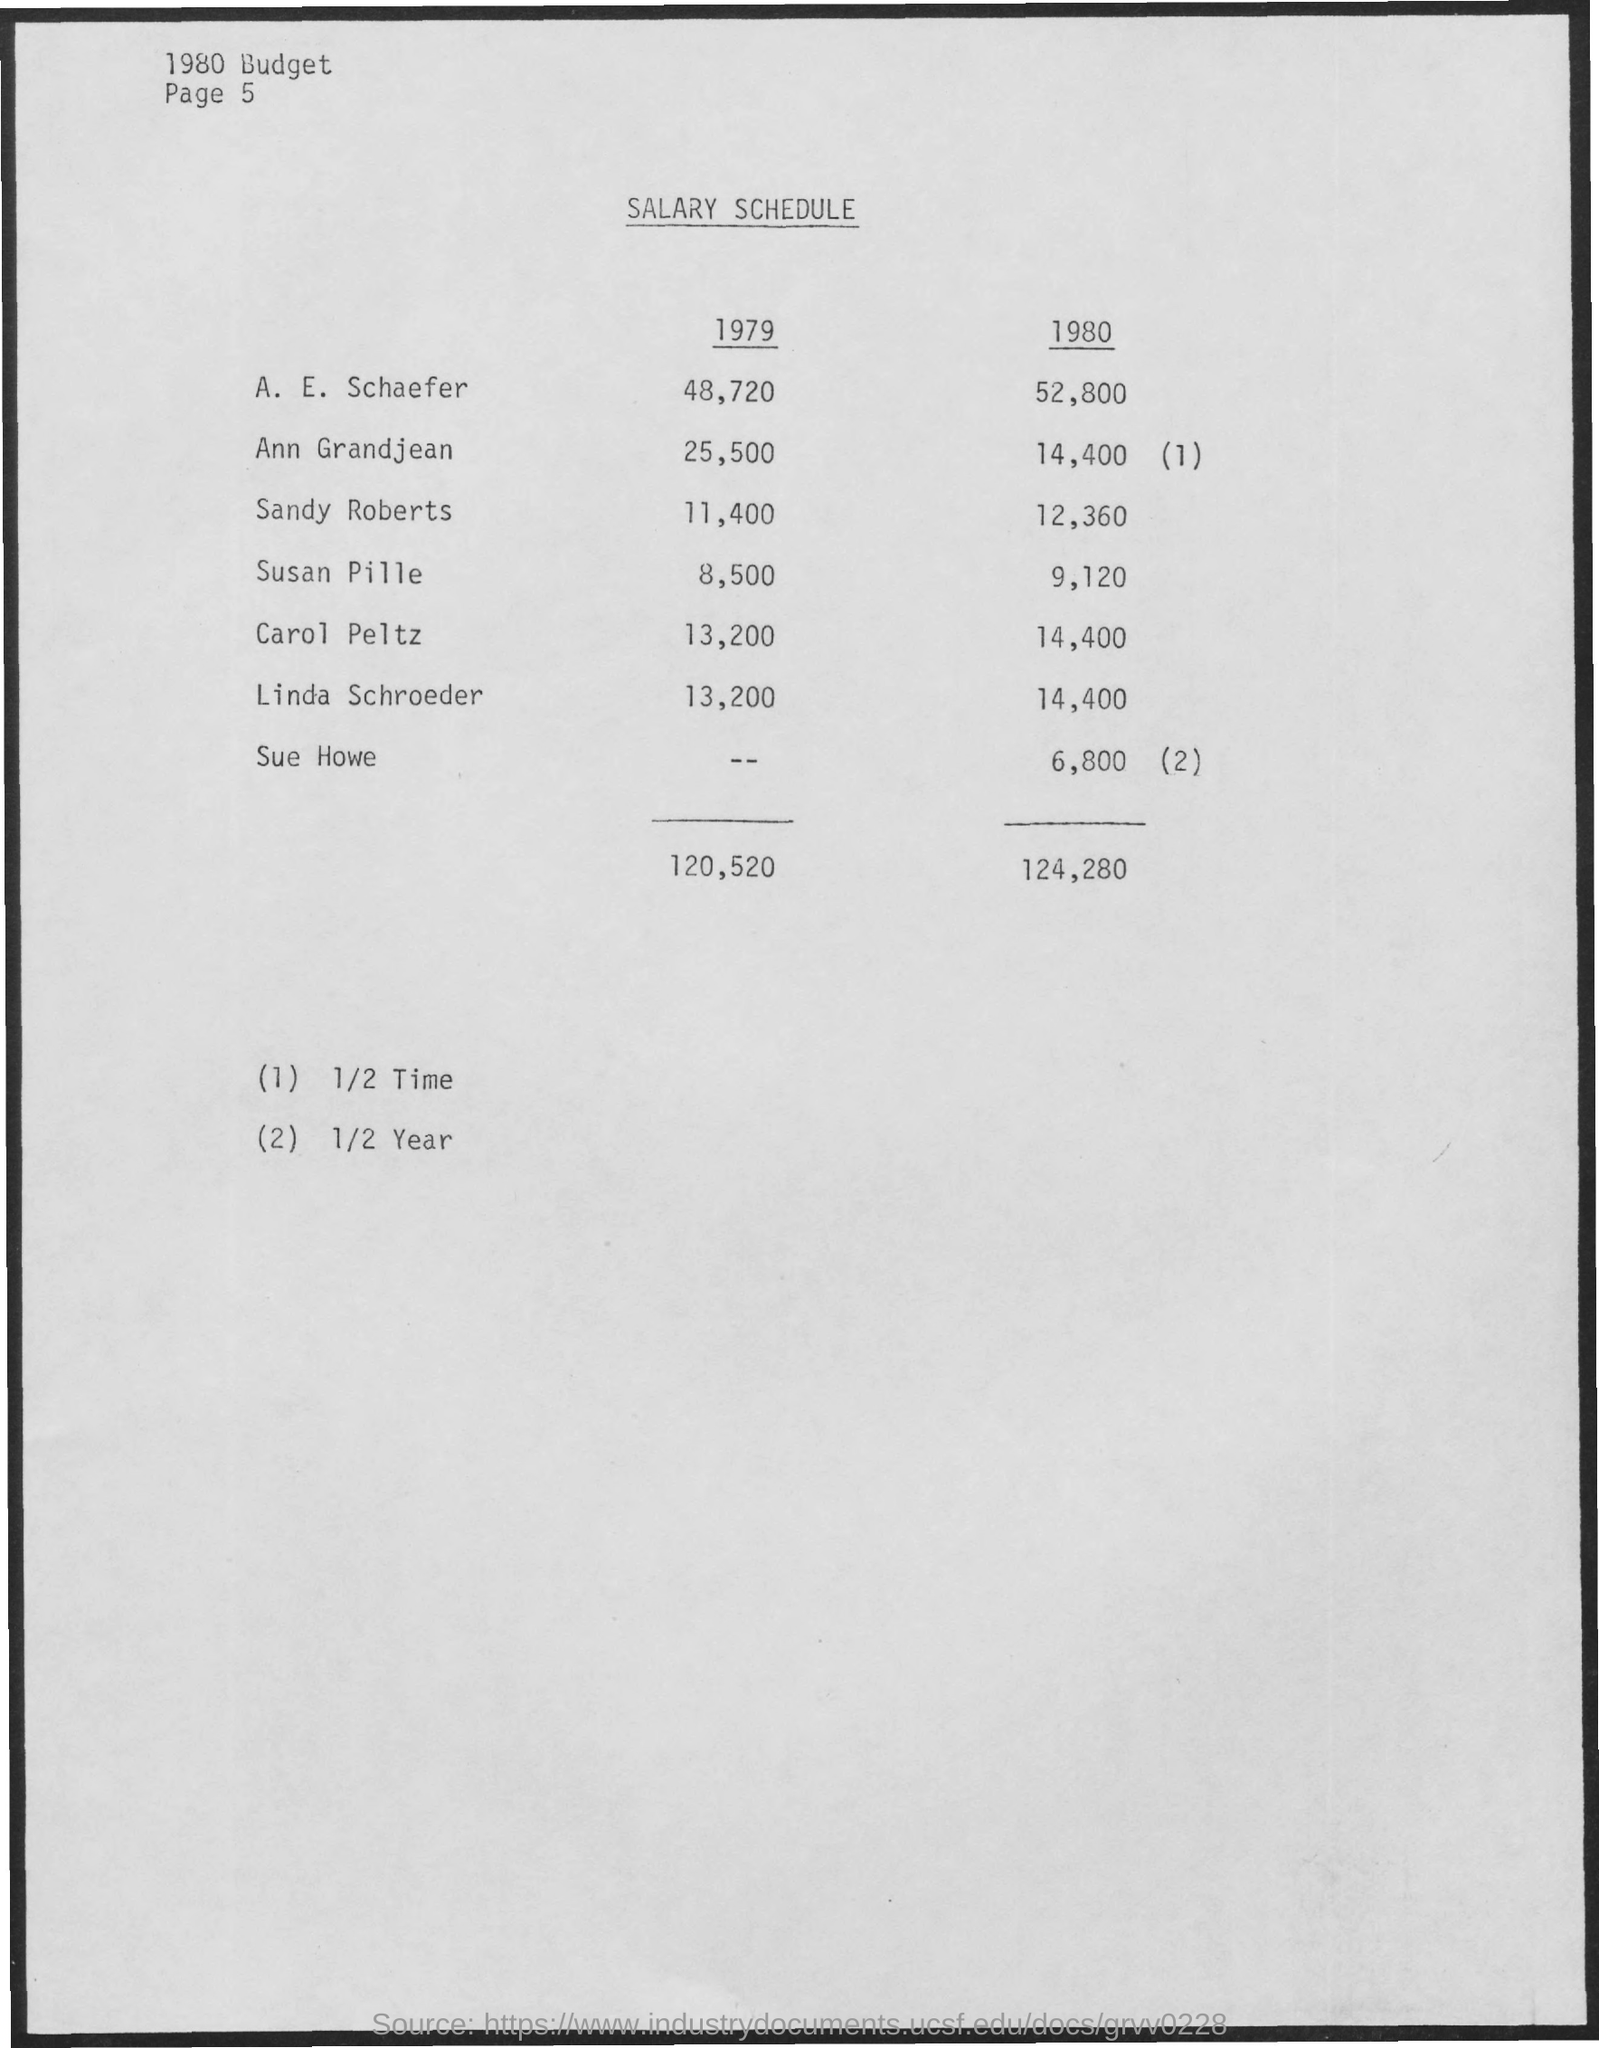Draw attention to some important aspects in this diagram. Carol Peltz's salary schedule for the year 1979 was 13,200. Ann Grandjean's salary schedule in 1979 was 25,500. In 1979, Sandy Roberts' salary schedule was 11,400. Ann Grandjean's salary in 1980 was 14,400 dollars. The salary schedule for A. E. Schaefer in 1980 was 52,800. 